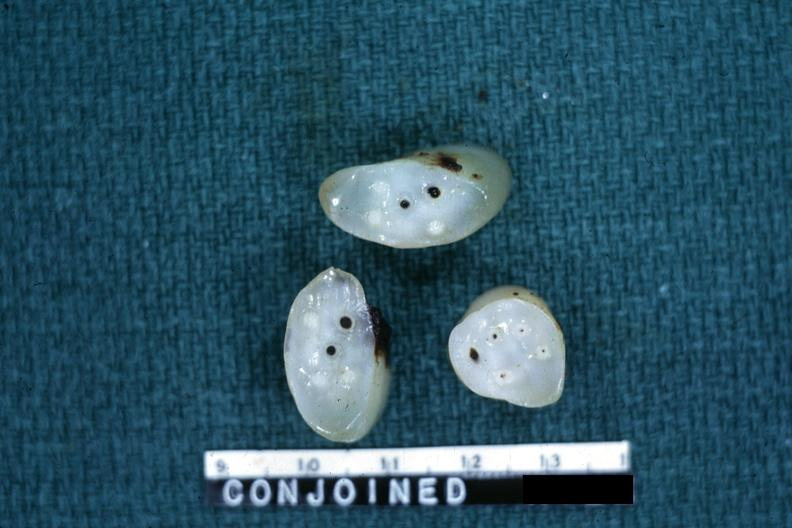s acute lymphocytic leukemia present?
Answer the question using a single word or phrase. No 